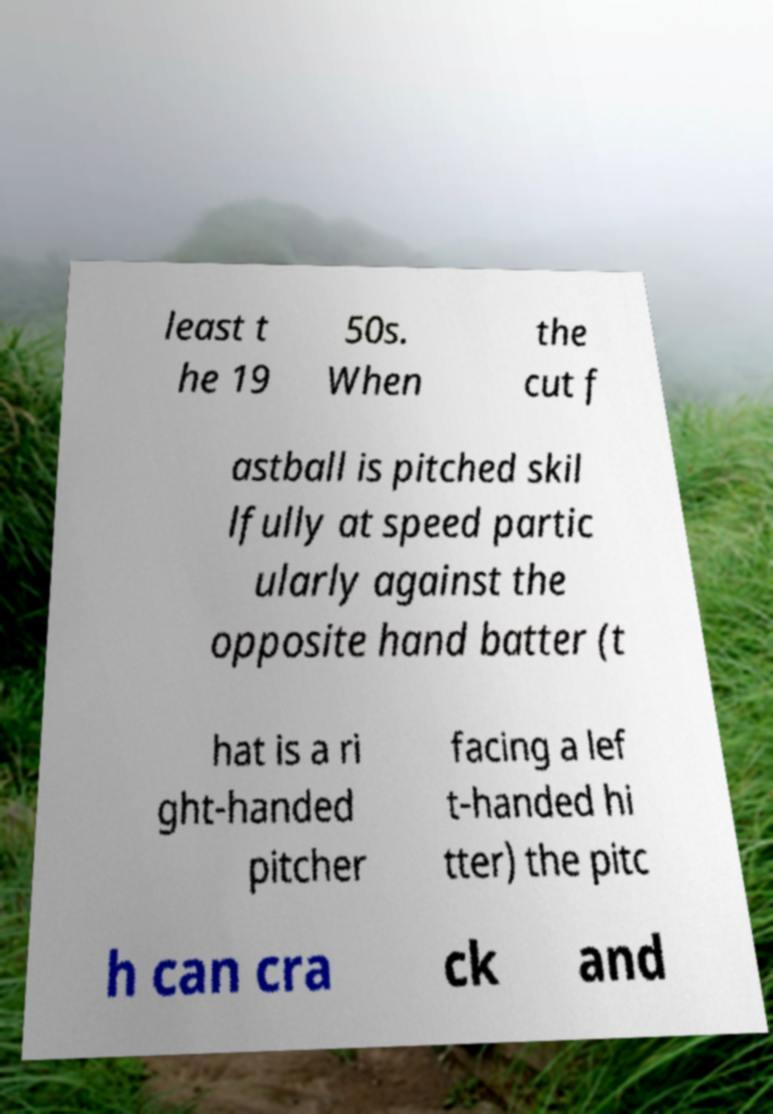Can you read and provide the text displayed in the image?This photo seems to have some interesting text. Can you extract and type it out for me? least t he 19 50s. When the cut f astball is pitched skil lfully at speed partic ularly against the opposite hand batter (t hat is a ri ght-handed pitcher facing a lef t-handed hi tter) the pitc h can cra ck and 